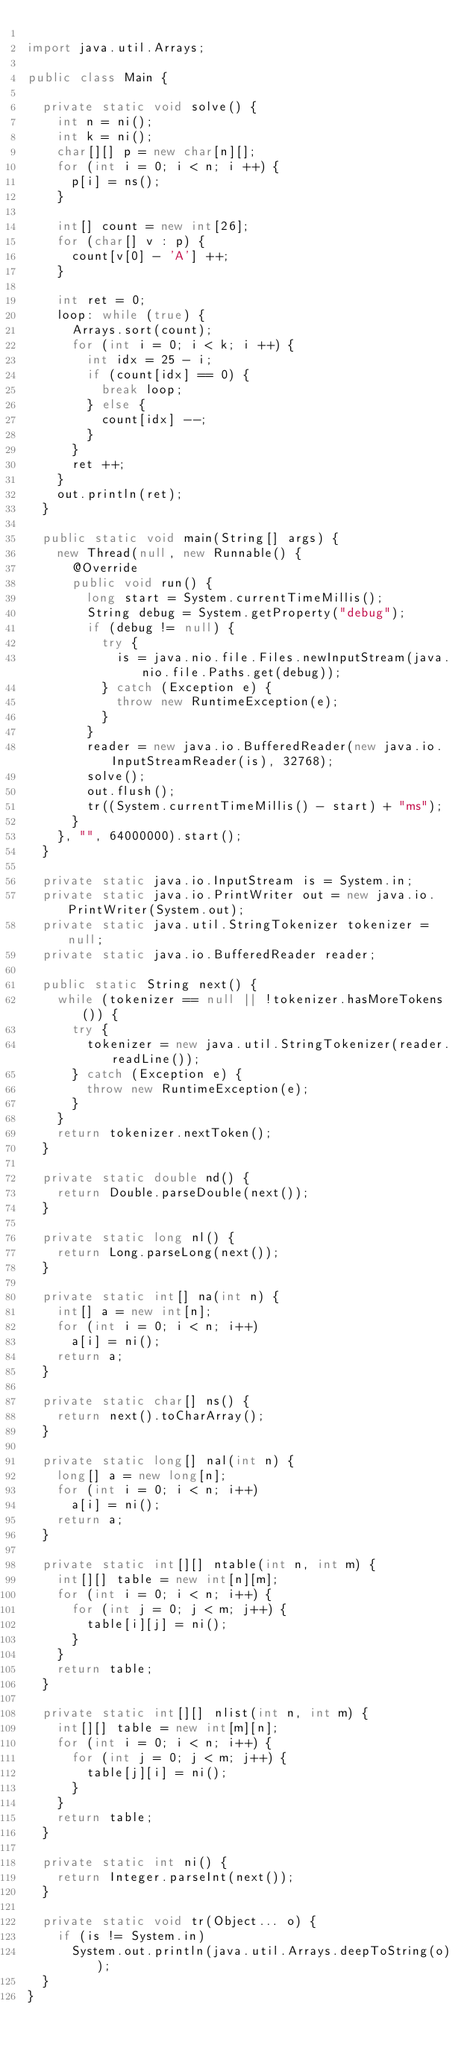Convert code to text. <code><loc_0><loc_0><loc_500><loc_500><_Java_>
import java.util.Arrays;

public class Main {

  private static void solve() {
    int n = ni();
    int k = ni();
    char[][] p = new char[n][];
    for (int i = 0; i < n; i ++) {
      p[i] = ns();
    }
    
    int[] count = new int[26];
    for (char[] v : p) {
      count[v[0] - 'A'] ++;
    }
    
    int ret = 0;
    loop: while (true) {
      Arrays.sort(count);
      for (int i = 0; i < k; i ++) {
        int idx = 25 - i;
        if (count[idx] == 0) {
          break loop;
        } else {
          count[idx] --;
        }
      }
      ret ++;
    }
    out.println(ret);
  }

  public static void main(String[] args) {
    new Thread(null, new Runnable() {
      @Override
      public void run() {
        long start = System.currentTimeMillis();
        String debug = System.getProperty("debug");
        if (debug != null) {
          try {
            is = java.nio.file.Files.newInputStream(java.nio.file.Paths.get(debug));
          } catch (Exception e) {
            throw new RuntimeException(e);
          }
        }
        reader = new java.io.BufferedReader(new java.io.InputStreamReader(is), 32768);
        solve();
        out.flush();
        tr((System.currentTimeMillis() - start) + "ms");
      }
    }, "", 64000000).start();
  }

  private static java.io.InputStream is = System.in;
  private static java.io.PrintWriter out = new java.io.PrintWriter(System.out);
  private static java.util.StringTokenizer tokenizer = null;
  private static java.io.BufferedReader reader;

  public static String next() {
    while (tokenizer == null || !tokenizer.hasMoreTokens()) {
      try {
        tokenizer = new java.util.StringTokenizer(reader.readLine());
      } catch (Exception e) {
        throw new RuntimeException(e);
      }
    }
    return tokenizer.nextToken();
  }

  private static double nd() {
    return Double.parseDouble(next());
  }

  private static long nl() {
    return Long.parseLong(next());
  }

  private static int[] na(int n) {
    int[] a = new int[n];
    for (int i = 0; i < n; i++)
      a[i] = ni();
    return a;
  }

  private static char[] ns() {
    return next().toCharArray();
  }

  private static long[] nal(int n) {
    long[] a = new long[n];
    for (int i = 0; i < n; i++)
      a[i] = ni();
    return a;
  }

  private static int[][] ntable(int n, int m) {
    int[][] table = new int[n][m];
    for (int i = 0; i < n; i++) {
      for (int j = 0; j < m; j++) {
        table[i][j] = ni();
      }
    }
    return table;
  }

  private static int[][] nlist(int n, int m) {
    int[][] table = new int[m][n];
    for (int i = 0; i < n; i++) {
      for (int j = 0; j < m; j++) {
        table[j][i] = ni();
      }
    }
    return table;
  }

  private static int ni() {
    return Integer.parseInt(next());
  }

  private static void tr(Object... o) {
    if (is != System.in)
      System.out.println(java.util.Arrays.deepToString(o));
  }
}
</code> 